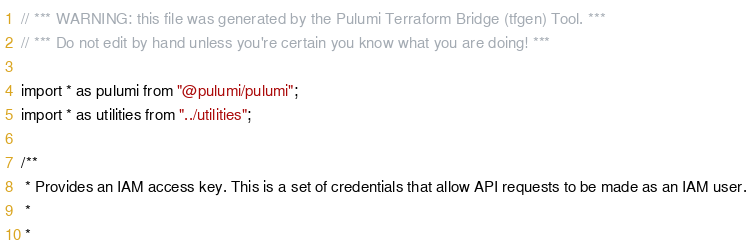<code> <loc_0><loc_0><loc_500><loc_500><_TypeScript_>// *** WARNING: this file was generated by the Pulumi Terraform Bridge (tfgen) Tool. ***
// *** Do not edit by hand unless you're certain you know what you are doing! ***

import * as pulumi from "@pulumi/pulumi";
import * as utilities from "../utilities";

/**
 * Provides an IAM access key. This is a set of credentials that allow API requests to be made as an IAM user.
 * 
 *</code> 